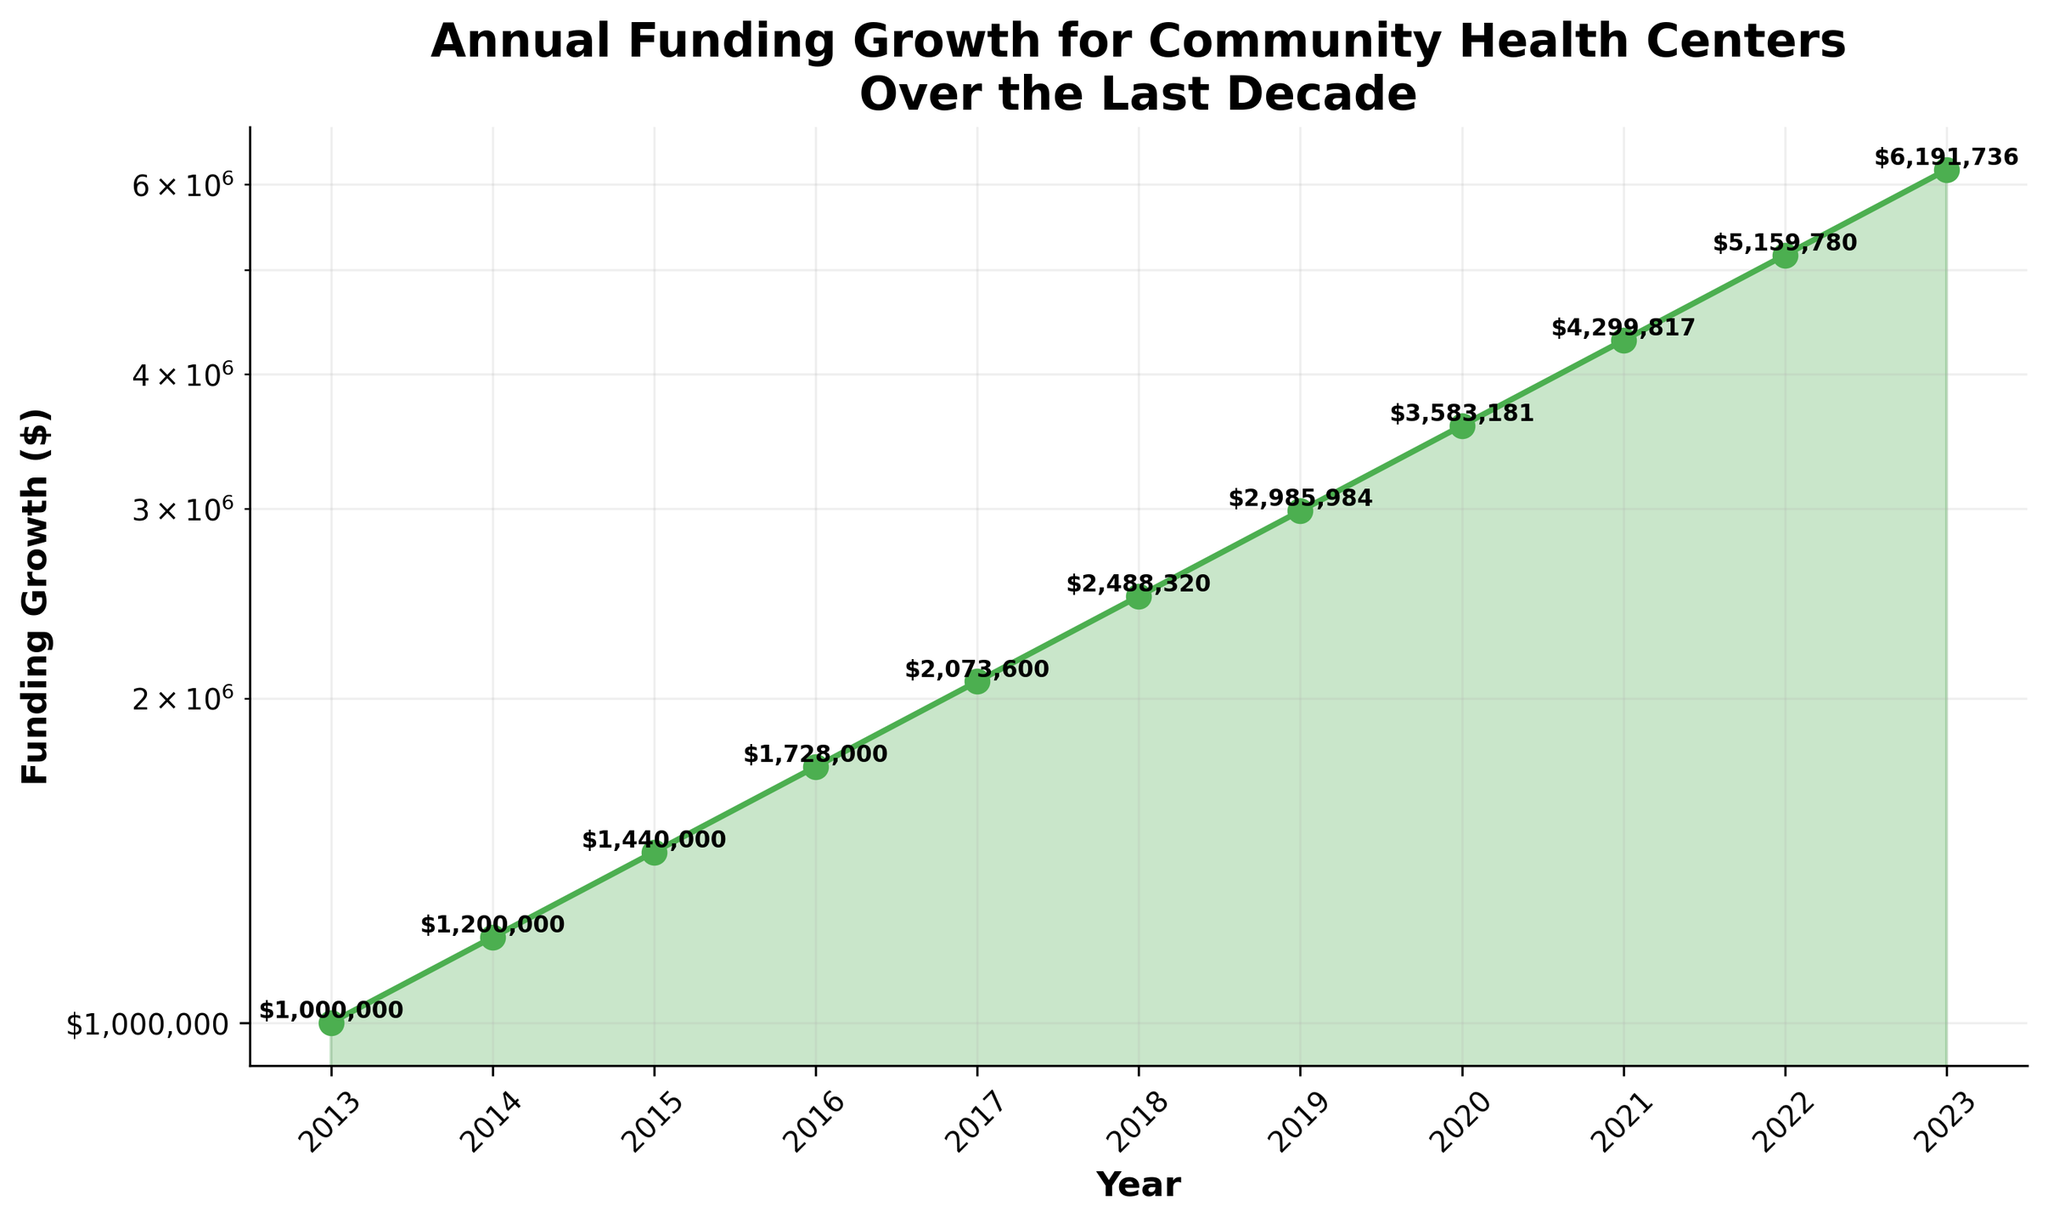What's the title of the figure? The title of the figure is displayed prominently at the top.
Answer: Annual Funding Growth for Community Health Centers Over the Last Decade What does the y-axis represent? The y-axis label is clearly indicated along the vertical axis of the plot.
Answer: Funding Growth ($) In which year did the funding reach approximately $3 million? The funding amount is marked on the y-axis and each data point is annotated; find the point labeled around $3 million.
Answer: 2019 By what factor did the funding grow from 2013 to 2023? To find the factor of growth, divide the funding amount in 2023 by the funding amount in 2013: $6,191,736 / $1,000,000.
Answer: 6.19 What was the funding growth in 2016 compared to 2015? The funding in 2016 and 2015 is marked near the respective years. Subtract the 2015 value from the 2016 value: $1,728,000 - $1,440,000.
Answer: $288,000 Which year experienced the highest rate of funding increase? To identify the highest rate of increase, observe where the funding growth line is steepest. Compare the differences between successive years.
Answer: 2016 How many years saw a funding growth of over $500,000 compared to the previous year? Check each year on the plot and compute the difference with its previous year. Count the number of years where the difference exceeds $500,000.
Answer: 4 years (2018-2021) Is the growth rate consistent throughout the decade? Assess the slopes between each pair of consecutive points on the plot. Faster increases have steeper slopes, while slower increases have gentler slopes.
Answer: No What's the average funding growth per year over the decade? Sum the yearly values and divide by the number of years. Total funding in 2023 = $6,191,736 and in 2013 = $1,000,000 (difference is $5,191,736). Divide by 10 years.
Answer: $519,174 per year Compare the funding in 2023 to that in 2019; what is the percentage increase? Calculate the percentage increase using the formula [(2023 value - 2019 value) / 2019 value] * 100: [(6,191,736 - 2,985,984) / 2,985,984] * 100.
Answer: Approximately 107.4% 